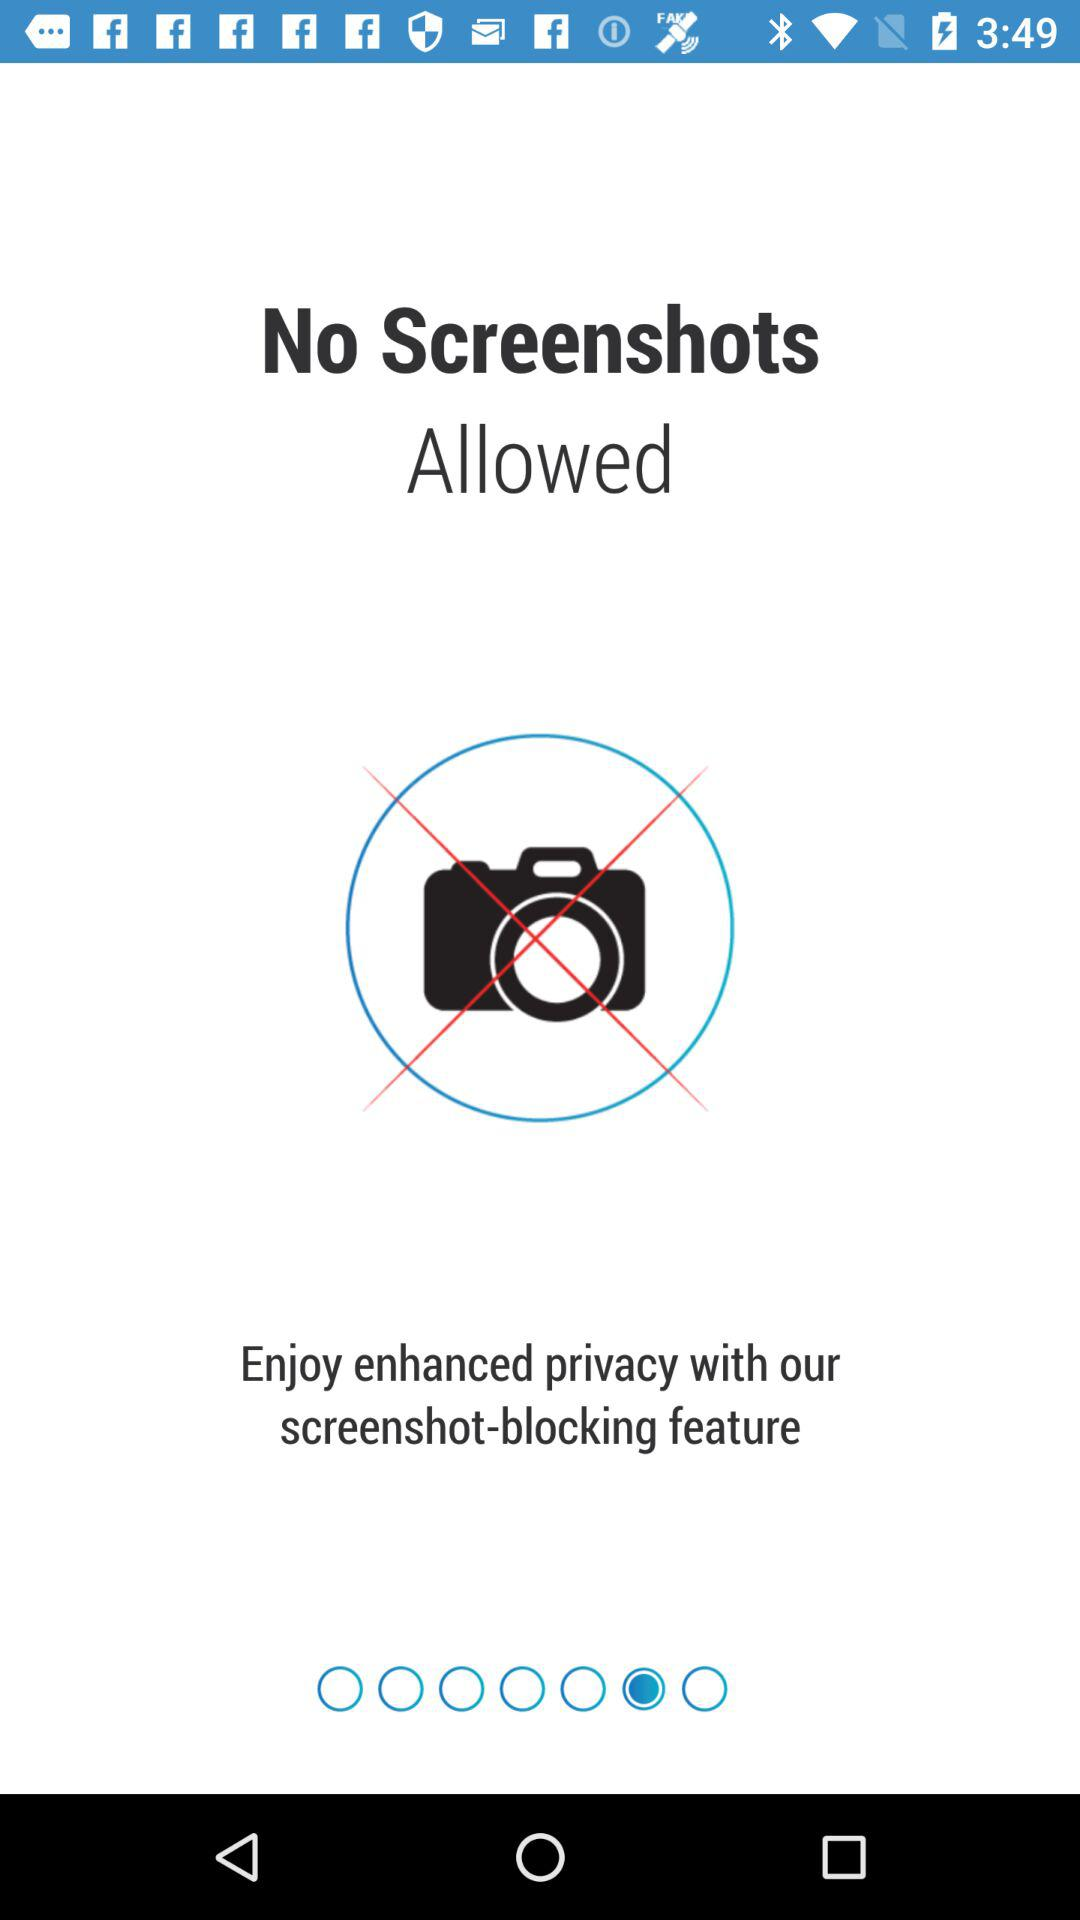Are screenshots allowed? Screenshorts are not allowed. 